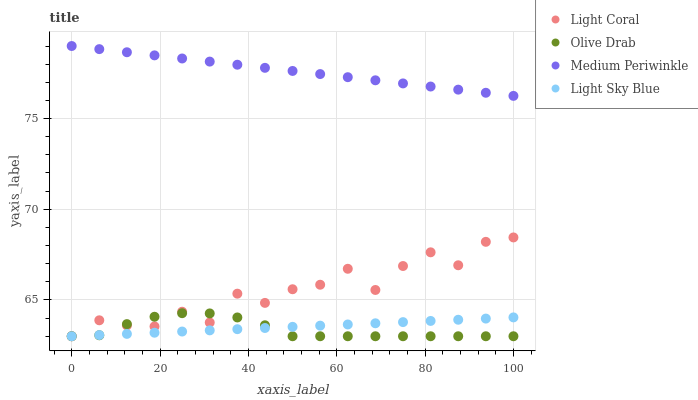Does Olive Drab have the minimum area under the curve?
Answer yes or no. Yes. Does Medium Periwinkle have the maximum area under the curve?
Answer yes or no. Yes. Does Light Sky Blue have the minimum area under the curve?
Answer yes or no. No. Does Light Sky Blue have the maximum area under the curve?
Answer yes or no. No. Is Light Sky Blue the smoothest?
Answer yes or no. Yes. Is Light Coral the roughest?
Answer yes or no. Yes. Is Medium Periwinkle the smoothest?
Answer yes or no. No. Is Medium Periwinkle the roughest?
Answer yes or no. No. Does Light Coral have the lowest value?
Answer yes or no. Yes. Does Medium Periwinkle have the lowest value?
Answer yes or no. No. Does Medium Periwinkle have the highest value?
Answer yes or no. Yes. Does Light Sky Blue have the highest value?
Answer yes or no. No. Is Light Sky Blue less than Medium Periwinkle?
Answer yes or no. Yes. Is Medium Periwinkle greater than Light Sky Blue?
Answer yes or no. Yes. Does Light Sky Blue intersect Light Coral?
Answer yes or no. Yes. Is Light Sky Blue less than Light Coral?
Answer yes or no. No. Is Light Sky Blue greater than Light Coral?
Answer yes or no. No. Does Light Sky Blue intersect Medium Periwinkle?
Answer yes or no. No. 